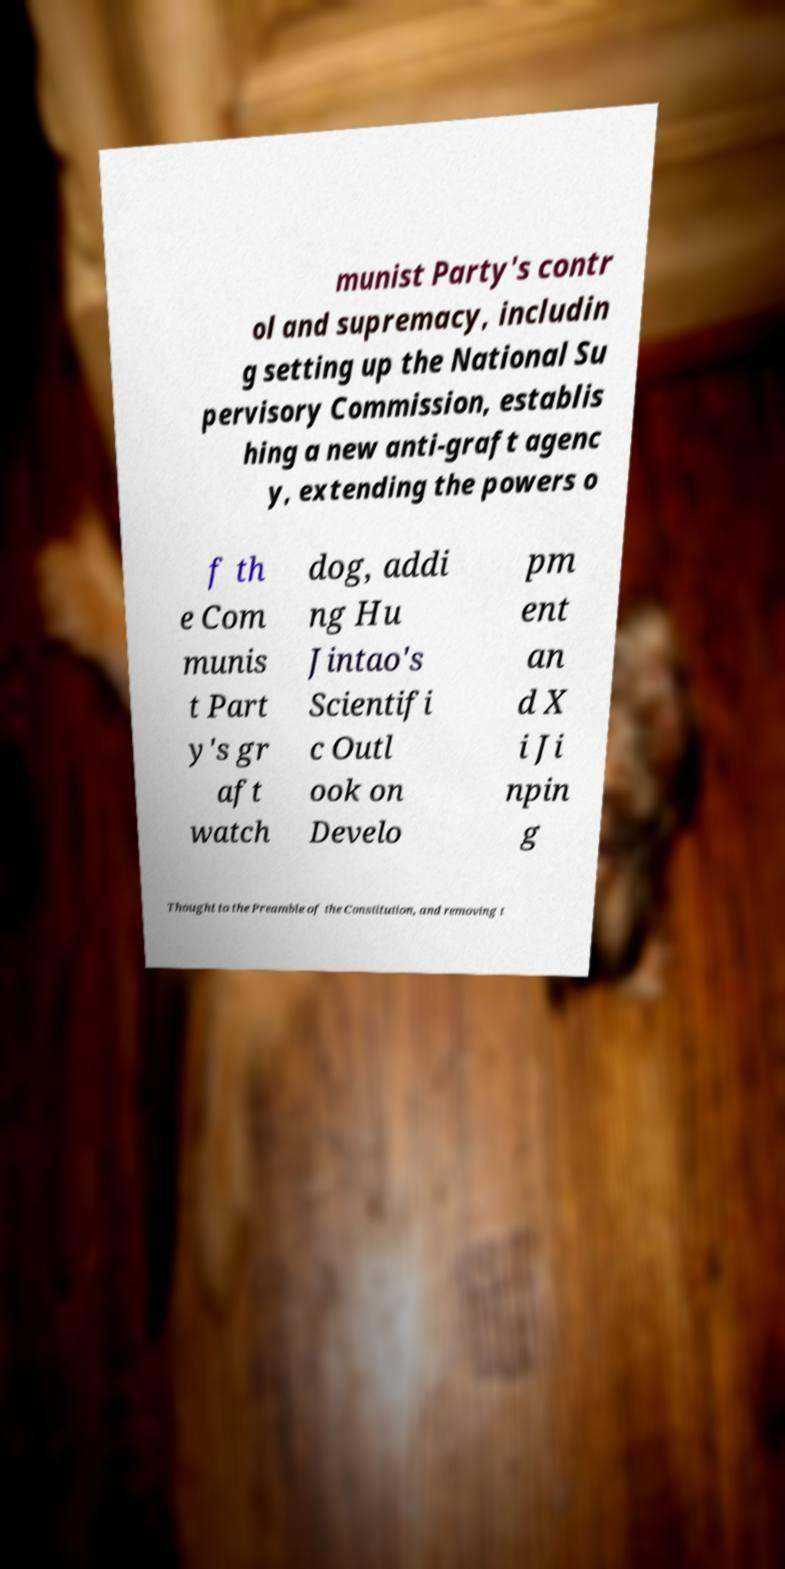For documentation purposes, I need the text within this image transcribed. Could you provide that? munist Party's contr ol and supremacy, includin g setting up the National Su pervisory Commission, establis hing a new anti-graft agenc y, extending the powers o f th e Com munis t Part y's gr aft watch dog, addi ng Hu Jintao's Scientifi c Outl ook on Develo pm ent an d X i Ji npin g Thought to the Preamble of the Constitution, and removing t 